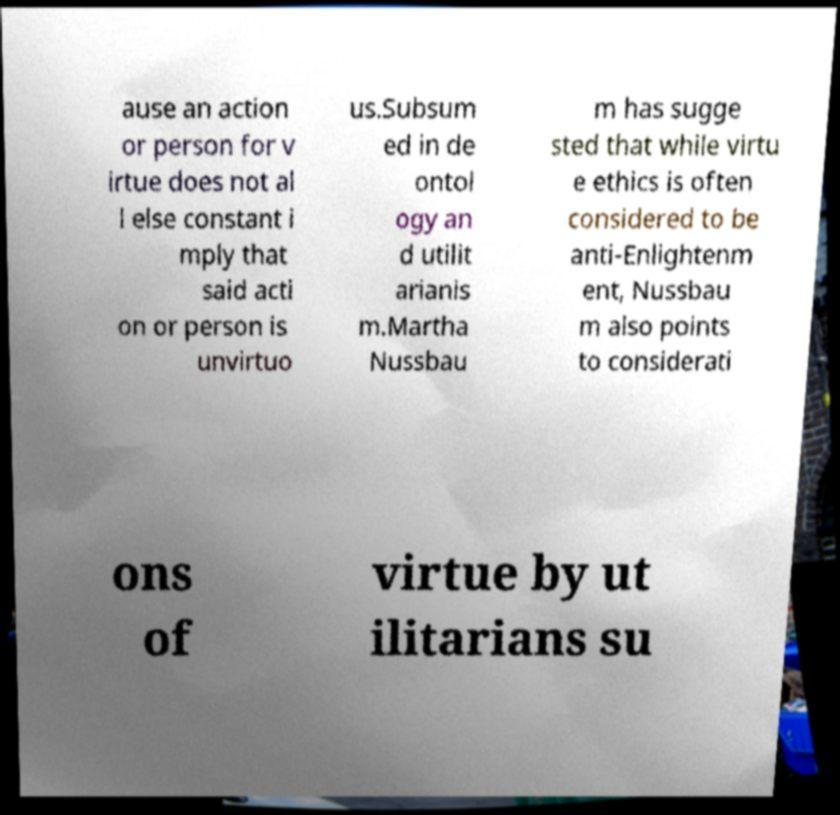Can you accurately transcribe the text from the provided image for me? ause an action or person for v irtue does not al l else constant i mply that said acti on or person is unvirtuo us.Subsum ed in de ontol ogy an d utilit arianis m.Martha Nussbau m has sugge sted that while virtu e ethics is often considered to be anti-Enlightenm ent, Nussbau m also points to considerati ons of virtue by ut ilitarians su 